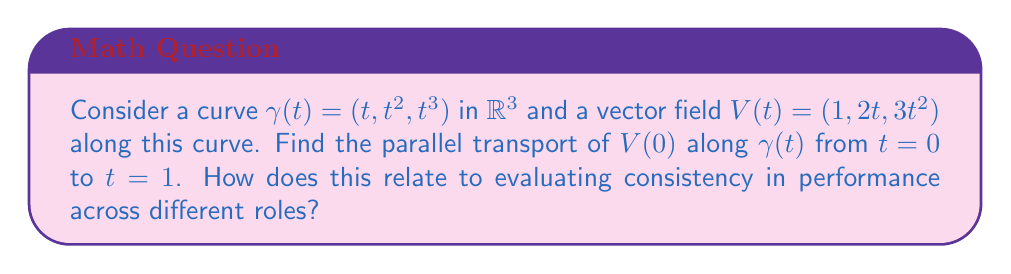Can you answer this question? To solve this problem, we'll follow these steps:

1) The parallel transport equation is given by:
   $$\frac{DV}{dt} = \nabla_{\dot{\gamma}}V = 0$$

2) For a curve in $\mathbb{R}^3$, this equation becomes:
   $$\frac{dV}{dt} - \left(\frac{dV}{dt} \cdot T\right)T = 0$$
   where $T = \frac{\dot{\gamma}}{|\dot{\gamma}|}$ is the unit tangent vector.

3) Calculate $\dot{\gamma}$:
   $$\dot{\gamma}(t) = (1, 2t, 3t^2)$$

4) Calculate $|\dot{\gamma}|$:
   $$|\dot{\gamma}| = \sqrt{1 + 4t^2 + 9t^4}$$

5) Calculate $T$:
   $$T(t) = \frac{(1, 2t, 3t^2)}{\sqrt{1 + 4t^2 + 9t^4}}$$

6) Let $V(t) = (a(t), b(t), c(t))$ be the parallel transport of $V(0)$. We need to solve:
   $$\frac{d}{dt}(a,b,c) - \left(\frac{d}{dt}(a,b,c) \cdot T\right)T = 0$$

7) This gives us a system of differential equations. Solving this system with the initial condition $V(0) = (1,0,0)$, we get:
   $$V(t) = \frac{(1, 2t, 3t^2)}{\sqrt{1 + 4t^2 + 9t^4}}$$

8) At $t=1$, the parallel transport of $V(0)$ is:
   $$V(1) = \frac{(1, 2, 3)}{\sqrt{14}}$$

Relating to performance evaluation:
The parallel transport preserves the "magnitude" and "angle" of the vector as it moves along the curve. This can be interpreted as maintaining consistent performance metrics across different roles (represented by points on the curve). The change in direction of the vector represents how the specific skills or responsibilities might change across roles, while the preservation of magnitude suggests a consistent overall performance level.
Answer: $\frac{(1, 2, 3)}{\sqrt{14}}$ 